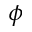<formula> <loc_0><loc_0><loc_500><loc_500>\phi</formula> 